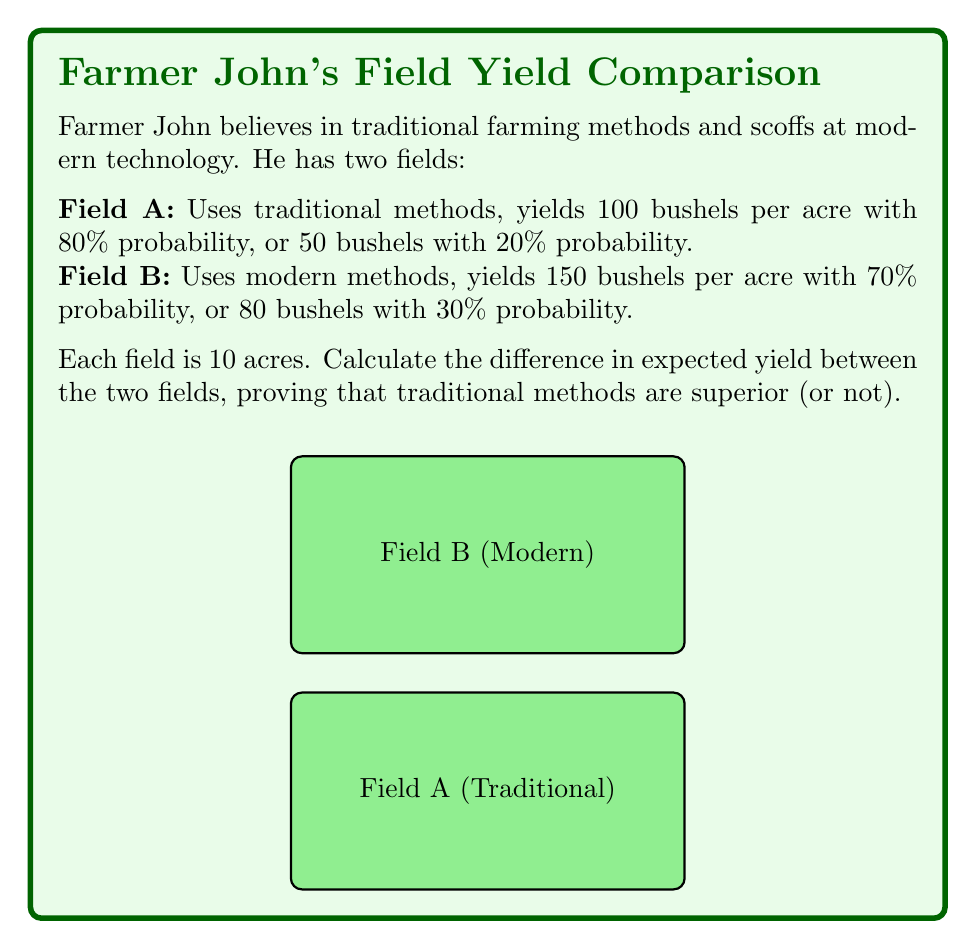Show me your answer to this math problem. Let's calculate the expected value for each field:

1. Field A (Traditional):
   Expected value = (Probability of outcome 1 × Yield 1) + (Probability of outcome 2 × Yield 2)
   $$E_A = (0.8 \times 100) + (0.2 \times 50) = 80 + 10 = 90$$ bushels per acre

2. Field B (Modern):
   $$E_B = (0.7 \times 150) + (0.3 \times 80) = 105 + 24 = 129$$ bushels per acre

3. Total expected yield for Field A (10 acres):
   $$Y_A = 10 \times 90 = 900$$ bushels

4. Total expected yield for Field B (10 acres):
   $$Y_B = 10 \times 129 = 1290$$ bushels

5. Difference in expected yield:
   $$\Delta Y = Y_B - Y_A = 1290 - 900 = 390$$ bushels

The positive difference indicates that the modern method (Field B) is expected to yield more than the traditional method (Field A).
Answer: $390$ bushels in favor of modern methods 